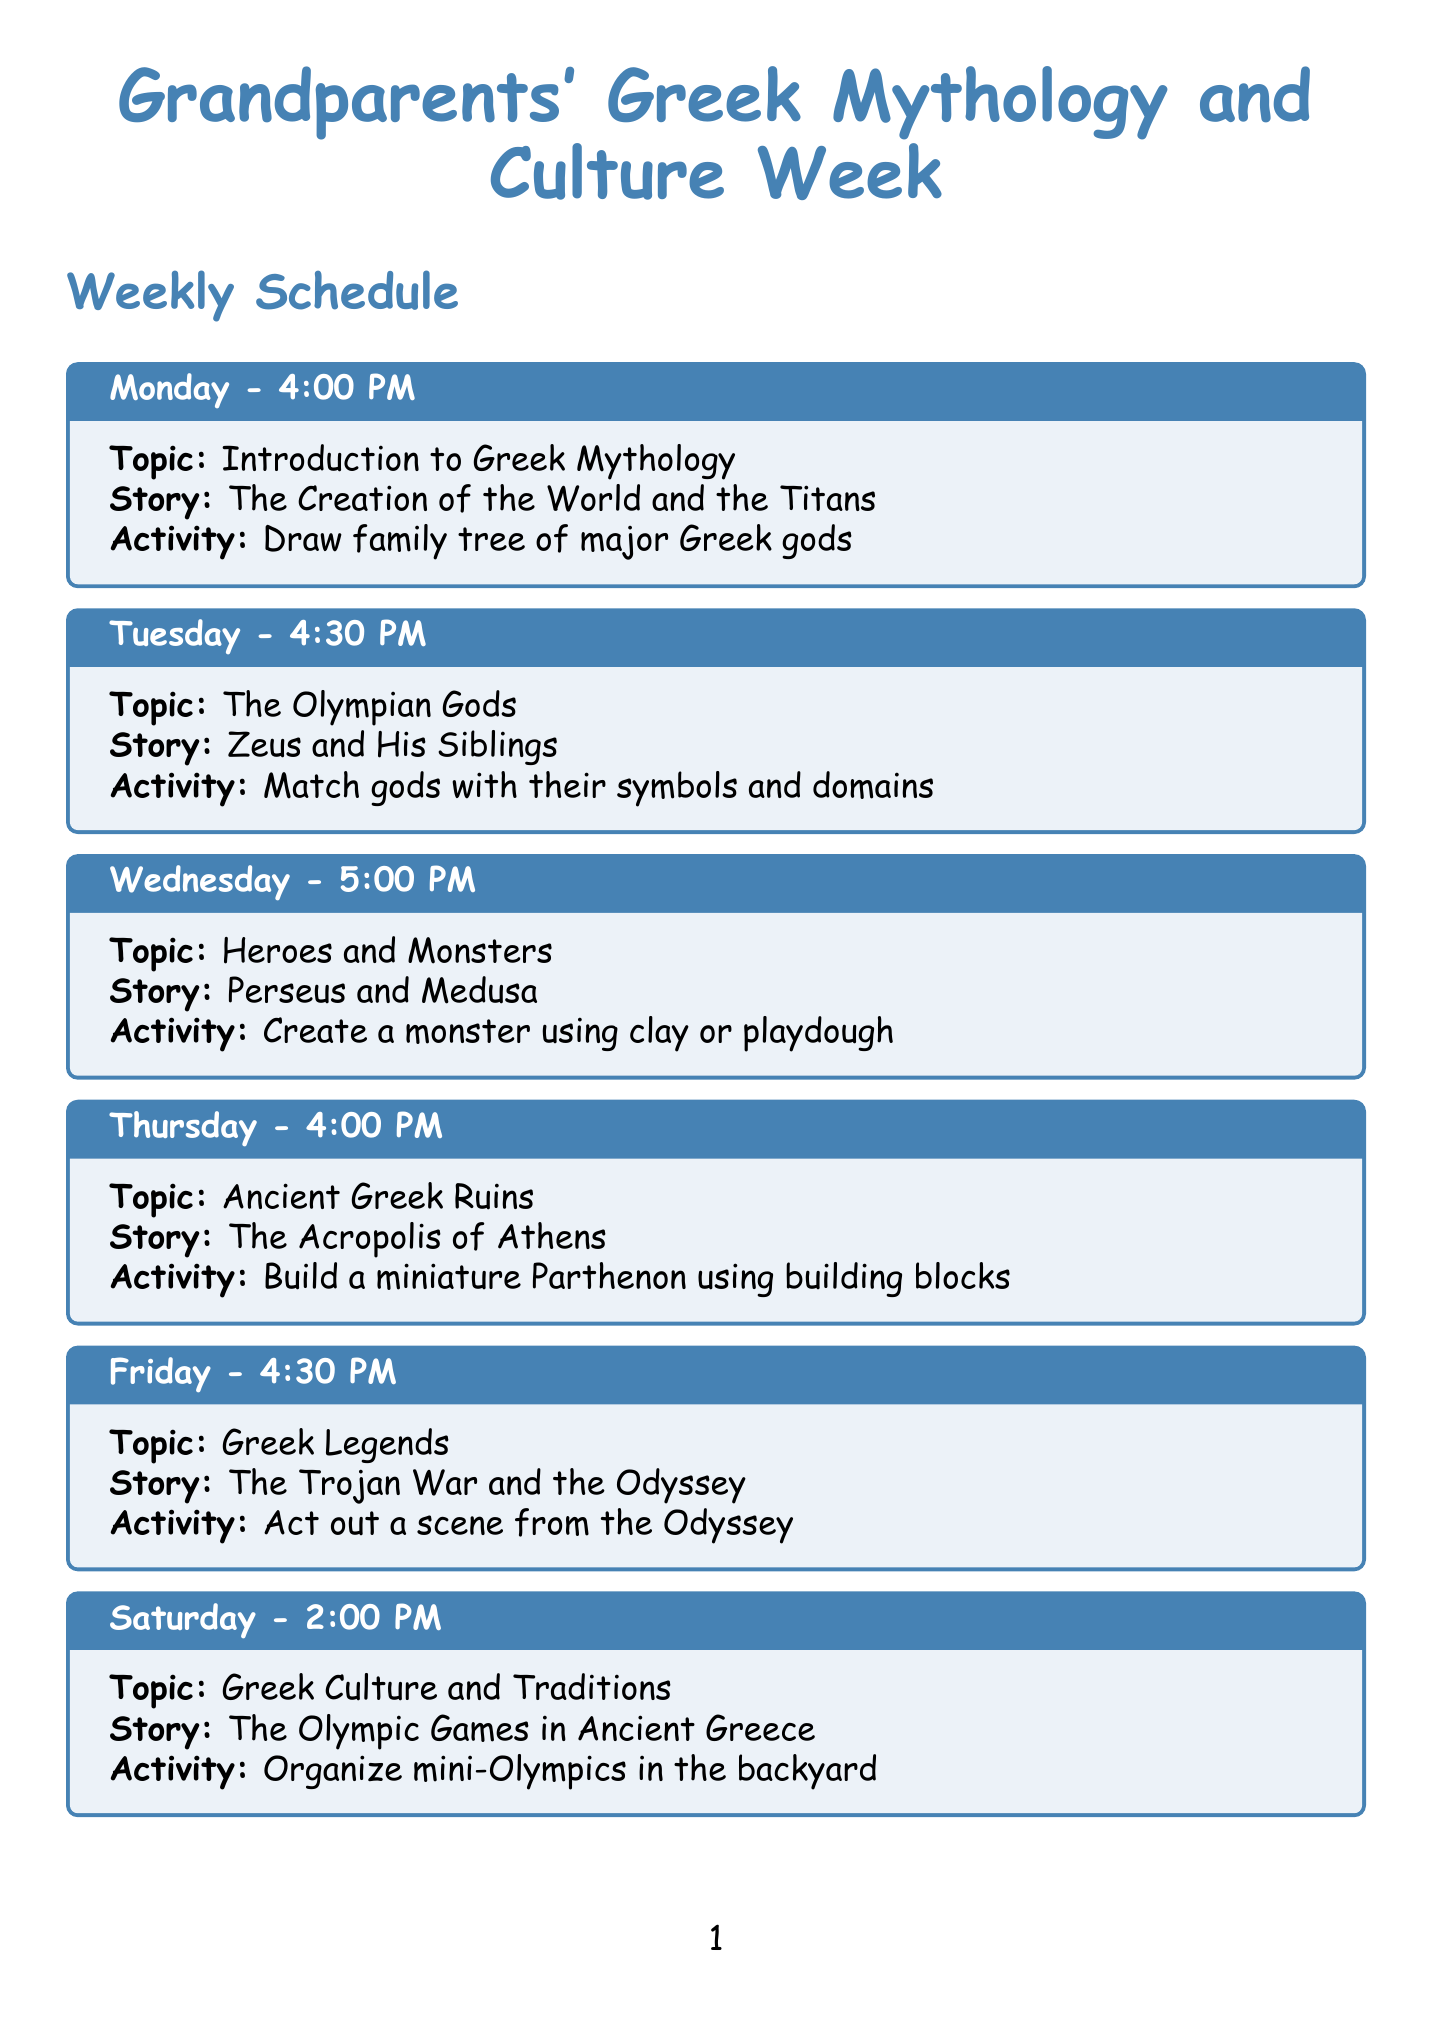What is the topic for Monday? The topic for Monday is found in the schedule section that lists activities for each day.
Answer: Introduction to Greek Mythology What time is the storytelling session on Friday? The time for the storytelling session on Friday is specified in the weekly schedule.
Answer: 4:30 PM Which ancient Greek ruin is covered on Thursday? The document mentions the specific ruin associated with the topic for Thursday in the schedule.
Answer: The Acropolis of Athens What activity is planned for Saturday? The activity for Saturday is listed alongside the topic and story in the schedule.
Answer: Organize mini-Olympics in the backyard How many locations of grandparents' experiences are mentioned? The total number of locations can be counted from the grandparents' experiences section.
Answer: Four What is the story shared on Tuesday? The story for Tuesday is detailed in the schedule and specifies the story associated with the discussed topic.
Answer: Zeus and His Siblings Which documentary is recommended in the additional resources? The documentary title is found under the additional resources section of the document.
Answer: The Greeks: Crucible of Civilization What myth does the Sunday session relate to? The specific myth mentioned for Sunday is detailed alongside the topic and activity in the schedule.
Answer: The Myth of Demeter and Persephone 